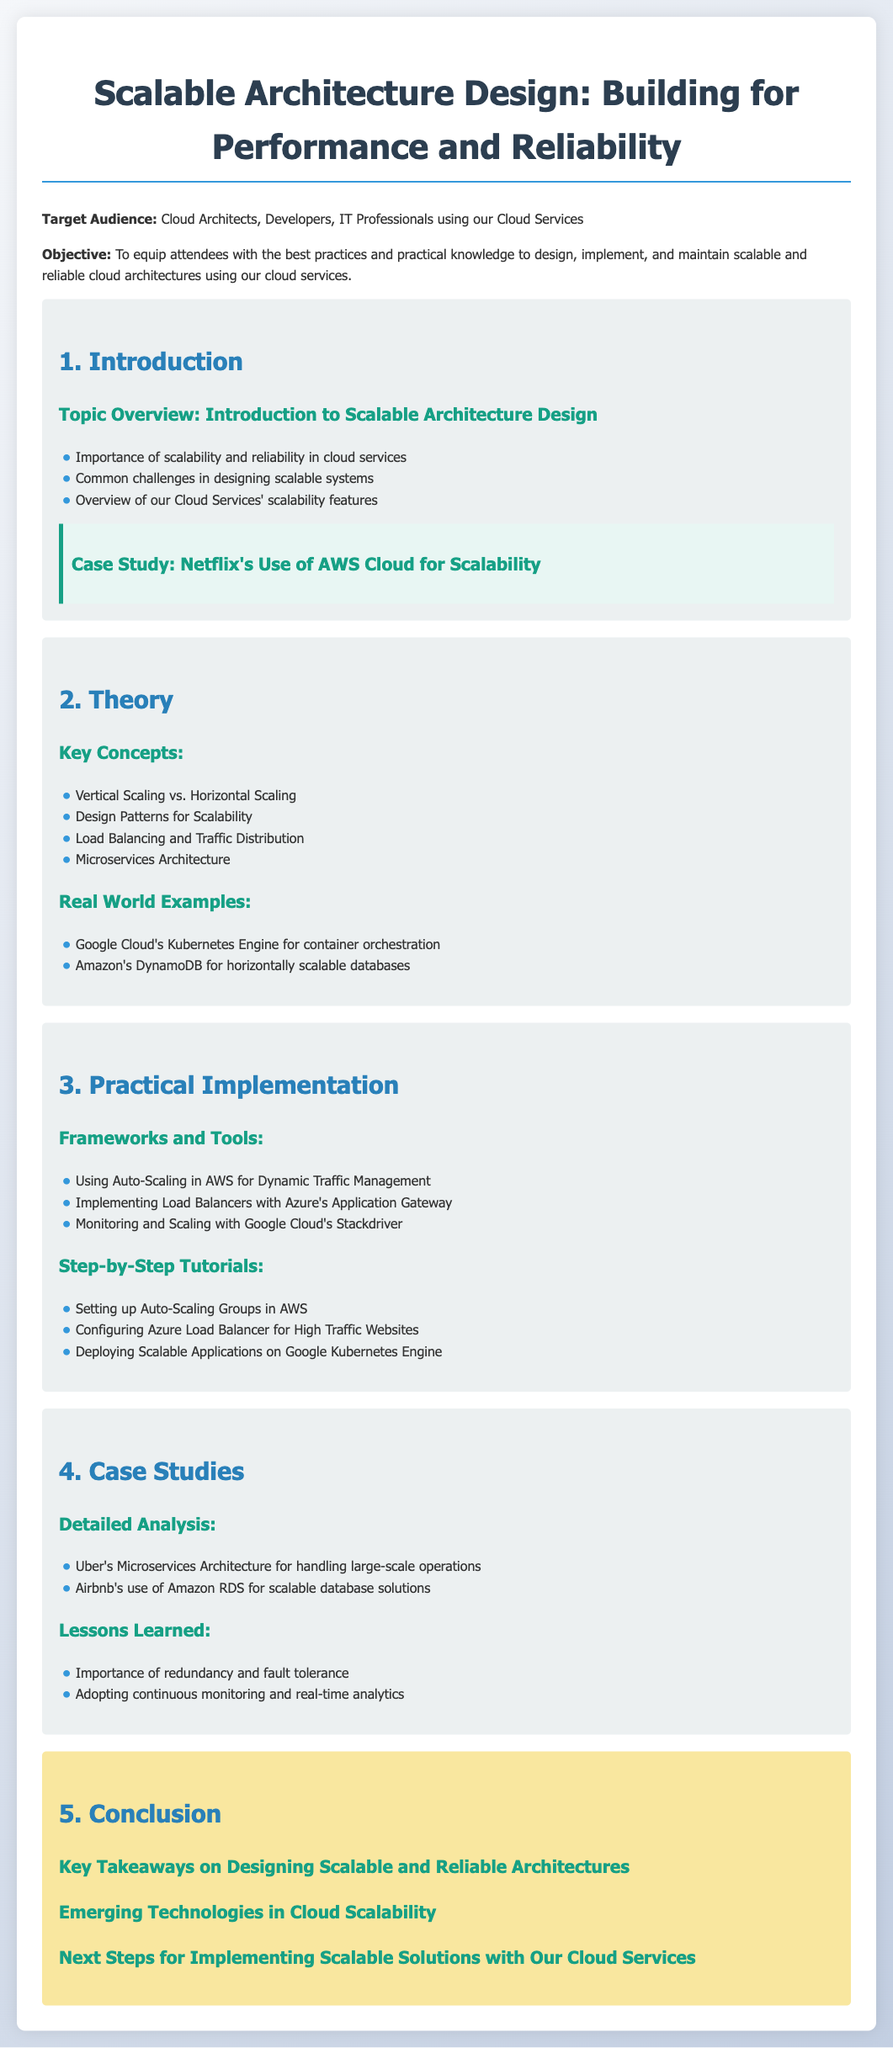What is the target audience for this lesson? The target audience specifies the group of individuals for whom the lesson is designed, which includes Cloud Architects, Developers, and IT Professionals using our Cloud Services.
Answer: Cloud Architects, Developers, IT Professionals What is the main objective of the lesson plan? The objective outlines the primary goal of the lesson, which is to equip attendees with best practices and practical knowledge to design, implement, and maintain scalable and reliable cloud architectures using our cloud services.
Answer: Best practices and practical knowledge Name one common challenge in designing scalable systems. The document mentions challenges in designing scalable systems, but does not list any specific challenges directly; it simply states "Common challenges in designing scalable systems."
Answer: Not specified What are two key concepts discussed in the theory section? The theory section contains key concepts related to scalable architecture design and mentions topics like Vertical Scaling and Load Balancing.
Answer: Vertical Scaling, Load Balancing What framework is used for dynamic traffic management? The practical implementation includes various tools and frameworks, specifically mentioning Auto-Scaling in AWS as a tool for managing traffic.
Answer: Auto-Scaling in AWS What is one lesson learned from the case studies? The case studies section provides insights on scalability lessons, highlighting the importance of redundancy and fault tolerance as essential learnings.
Answer: Redundancy and fault tolerance How many step-by-step tutorials are listed in the practical implementation section? The practical implementation part includes three specific step-by-step tutorials that guide implementing scalable solutions.
Answer: Three What is highlighted as a key takeaway on designing scalable architectures? The conclusion section summarizes crucial insights gained through the lesson, but does not specify a single takeaway, discussing multiple key takeaways in general.
Answer: Not specified What technology is mentioned for container orchestration? The real-world examples section lists Google Cloud's Kubernetes Engine as a technology used for managing container orchestration efficiently.
Answer: Google Cloud's Kubernetes Engine 